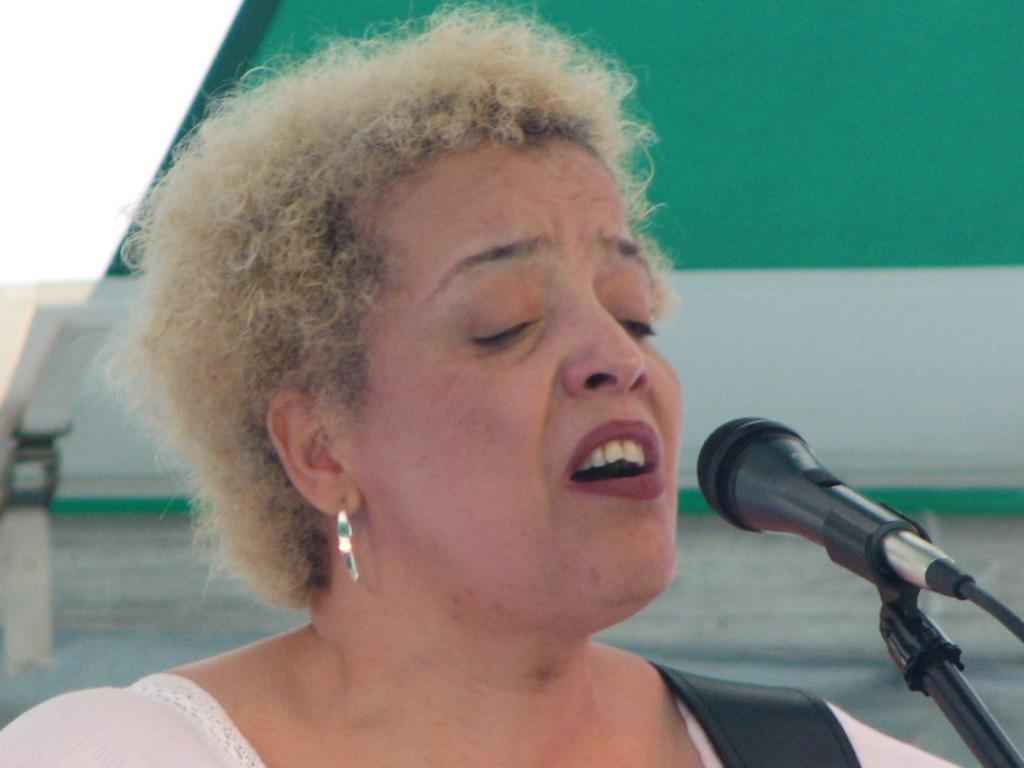Who is the main subject in the image? There is a lady in the image. What is the lady wearing in the image? The lady is wearing earrings. What object is in front of the lady in the image? There is a microphone with a mic stand in front of the lady. What can be seen behind the lady in the image? There is a wall in the background of the image. What fact can be seen looking at the lady's face in the image? There is no specific fact that can be seen looking at the lady's face in the image. 